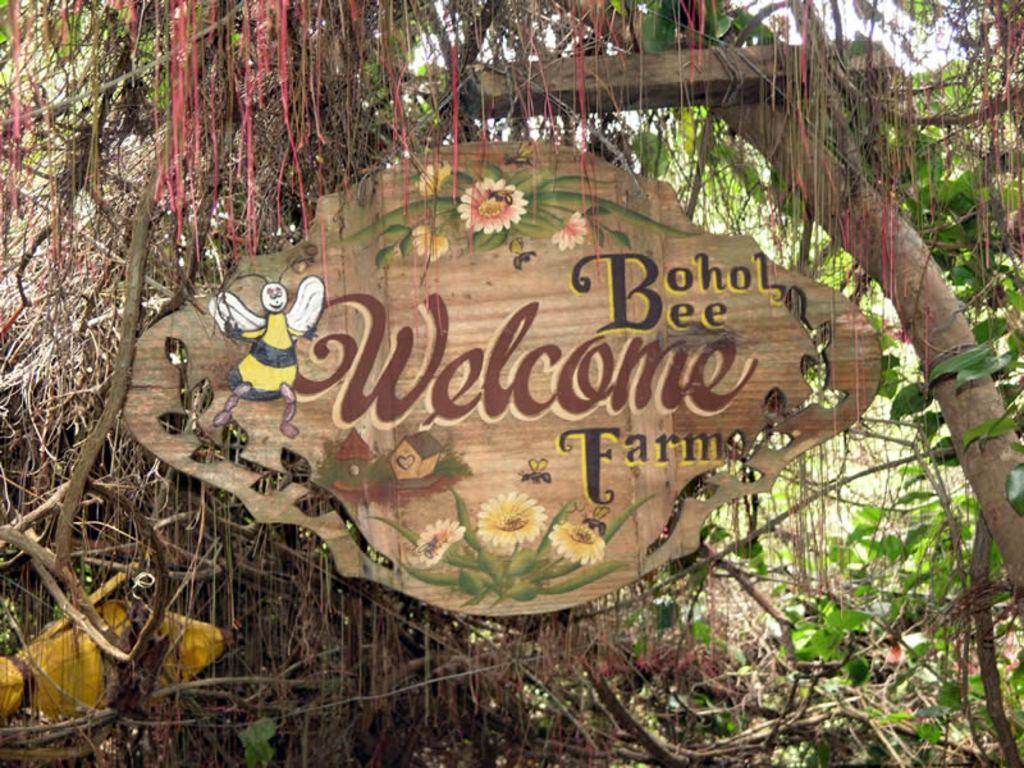Could you give a brief overview of what you see in this image? In this image, this looks like a name board with a design on it. These are the trees with branches and leaves. 